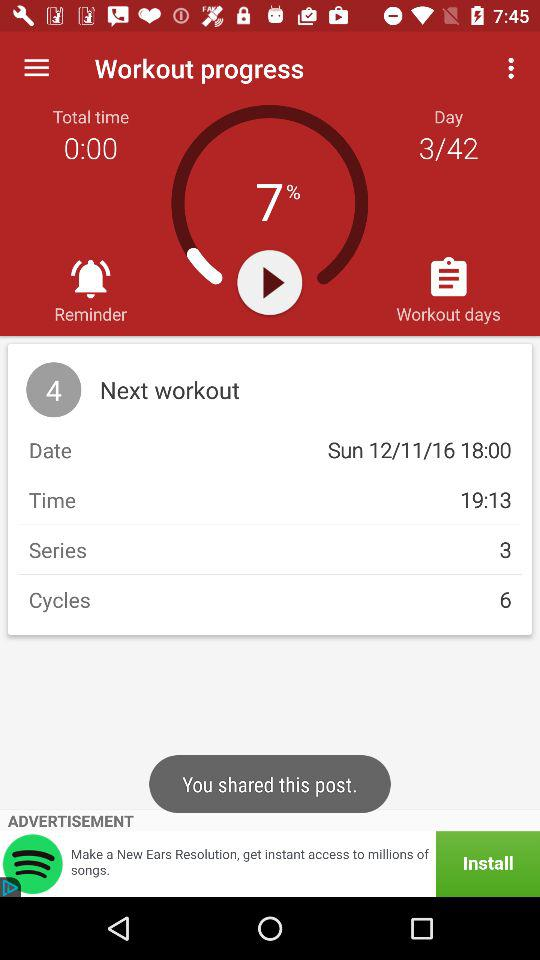How many days in total are required for the workout? There are 42 days required for the workout. 